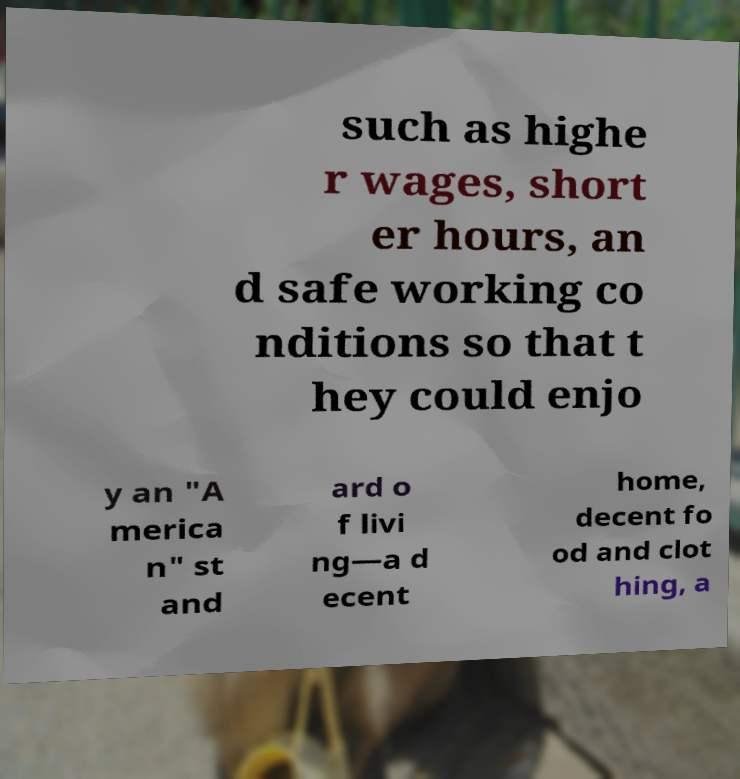What messages or text are displayed in this image? I need them in a readable, typed format. such as highe r wages, short er hours, an d safe working co nditions so that t hey could enjo y an "A merica n" st and ard o f livi ng—a d ecent home, decent fo od and clot hing, a 